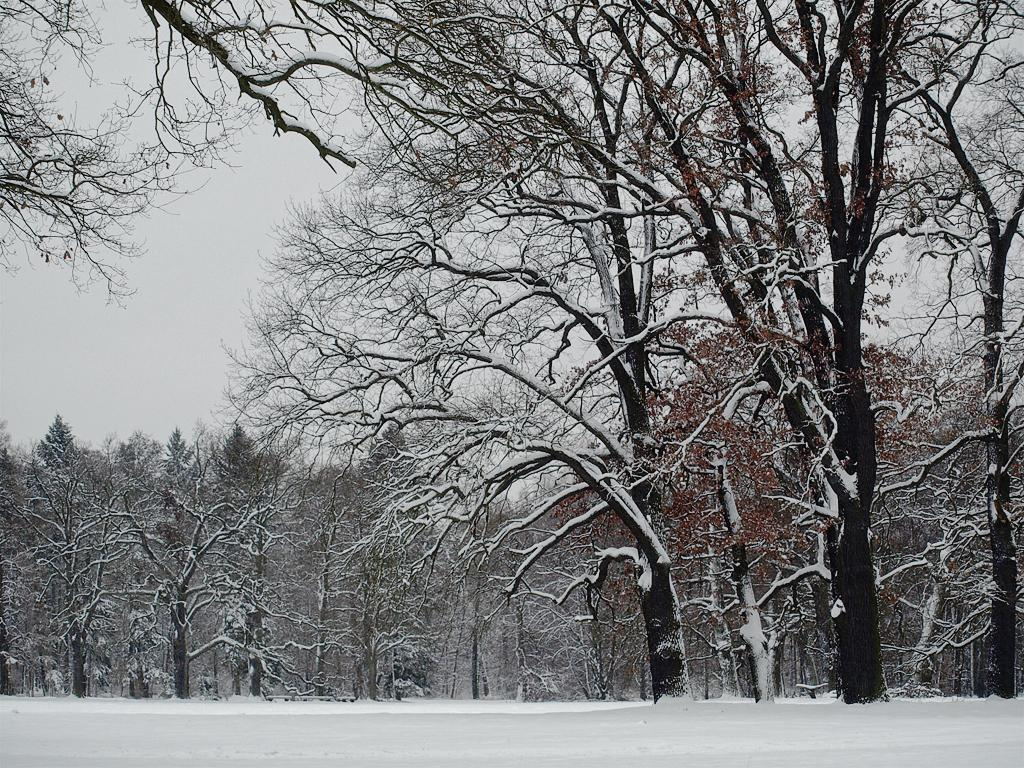What type of weather condition is depicted at the bottom of the image? There is snow at the bottom of the image. What can be seen in the background of the image? There are trees in the background of the image. Are the trees covered in snow as well? Yes, there is snow on the trees in the image. Can you see any veins on the trees in the image? There is no mention of veins on the trees in the image, and it is not possible to see veins on trees in a photograph. 